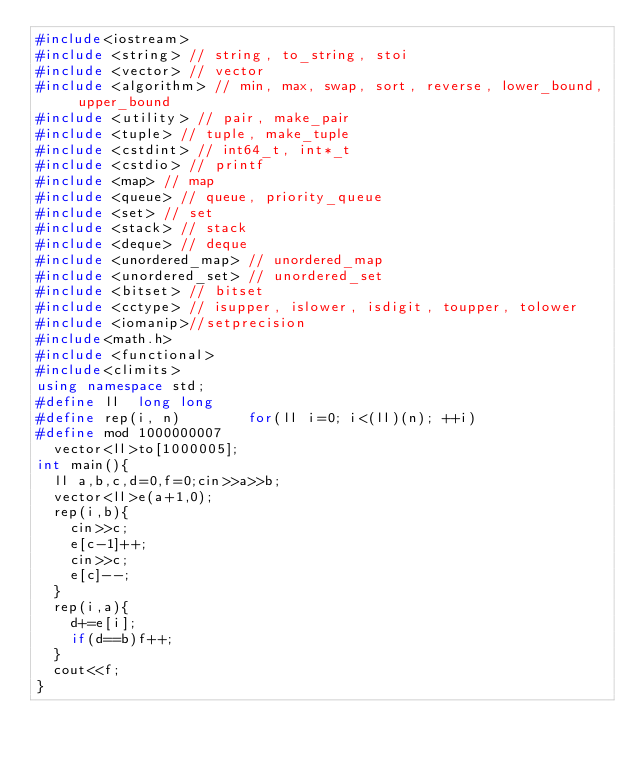<code> <loc_0><loc_0><loc_500><loc_500><_C++_>#include<iostream>
#include <string> // string, to_string, stoi
#include <vector> // vector
#include <algorithm> // min, max, swap, sort, reverse, lower_bound, upper_bound
#include <utility> // pair, make_pair
#include <tuple> // tuple, make_tuple
#include <cstdint> // int64_t, int*_t
#include <cstdio> // printf
#include <map> // map
#include <queue> // queue, priority_queue
#include <set> // set
#include <stack> // stack
#include <deque> // deque
#include <unordered_map> // unordered_map
#include <unordered_set> // unordered_set
#include <bitset> // bitset
#include <cctype> // isupper, islower, isdigit, toupper, tolower
#include <iomanip>//setprecision
#include<math.h>
#include <functional>
#include<climits>
using namespace std;
#define ll  long long 
#define rep(i, n)        for(ll i=0; i<(ll)(n); ++i)
#define mod 1000000007
  vector<ll>to[1000005];
int main(){
  ll a,b,c,d=0,f=0;cin>>a>>b;
  vector<ll>e(a+1,0);
  rep(i,b){
    cin>>c;
    e[c-1]++;
    cin>>c;
    e[c]--;
  }
  rep(i,a){
    d+=e[i];
    if(d==b)f++;
  }
  cout<<f;
}

</code> 